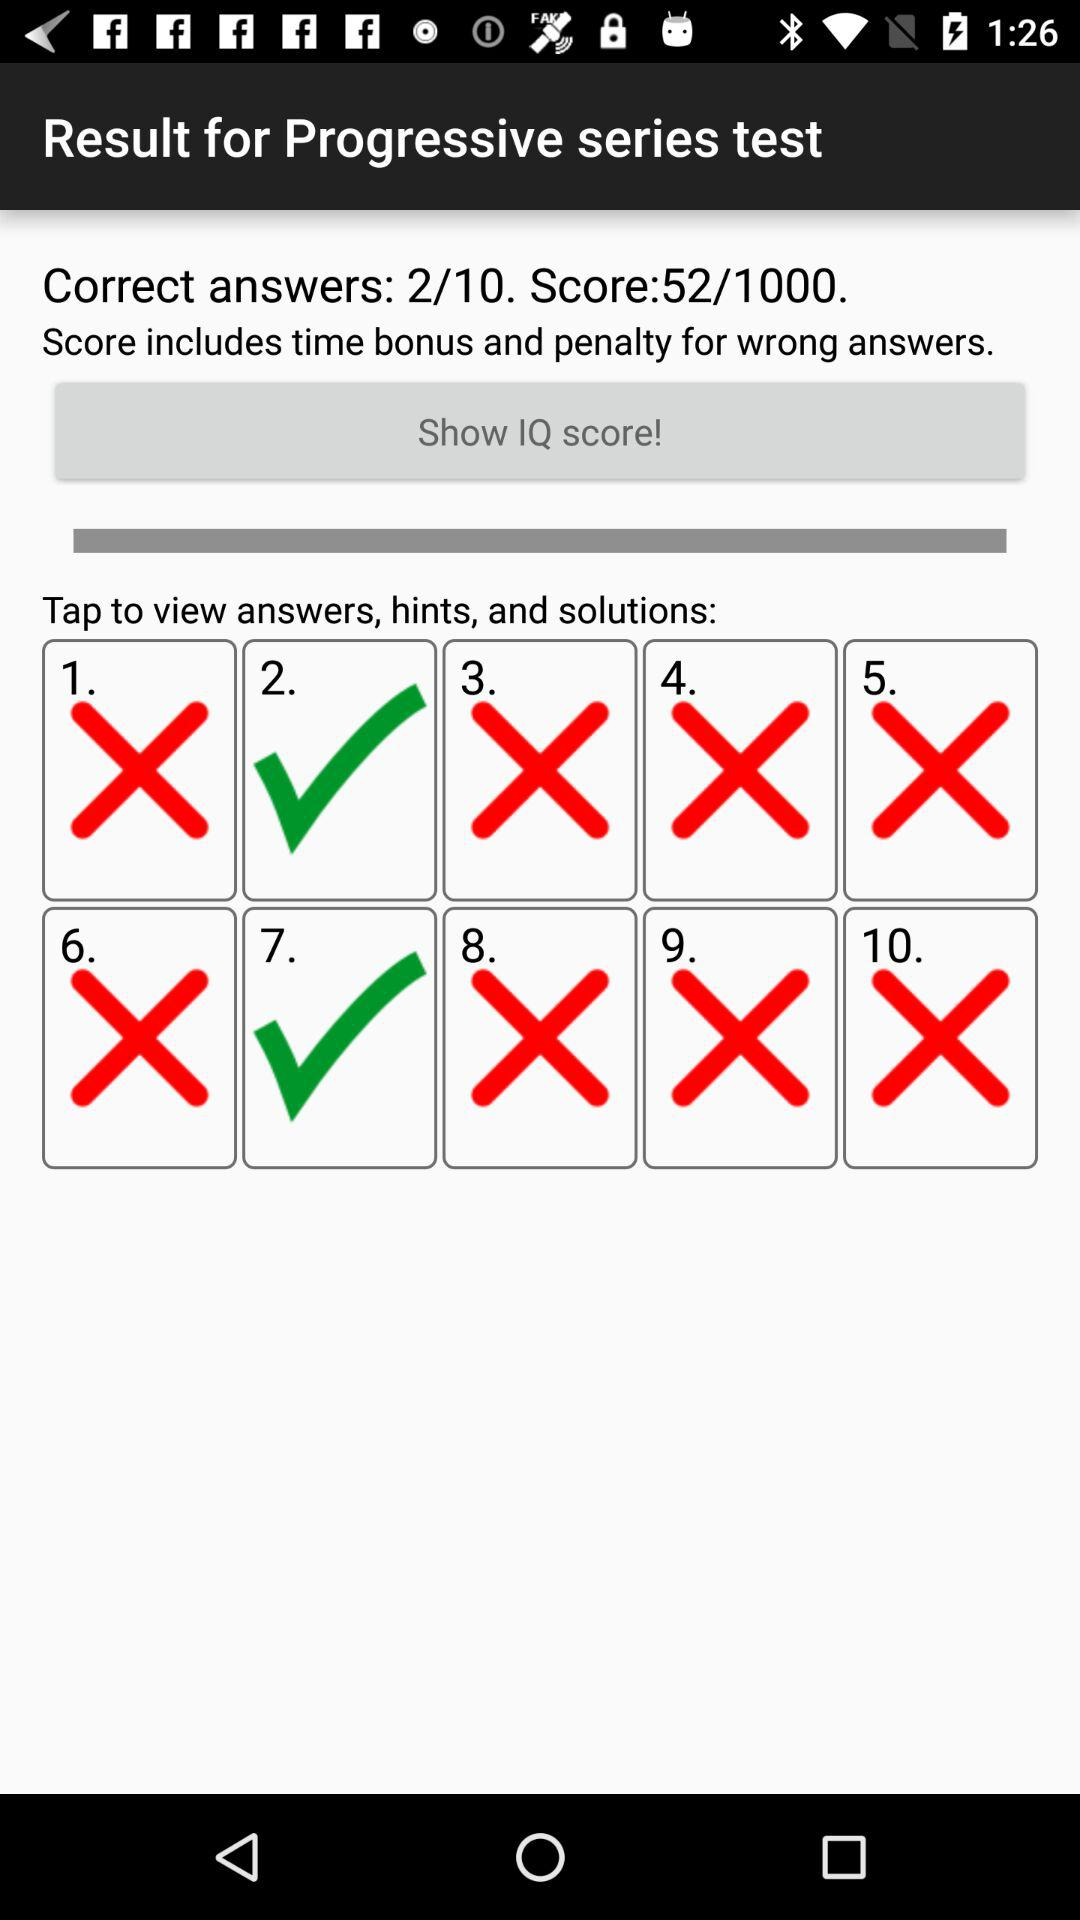How many answers are there in total?
Answer the question using a single word or phrase. 10 